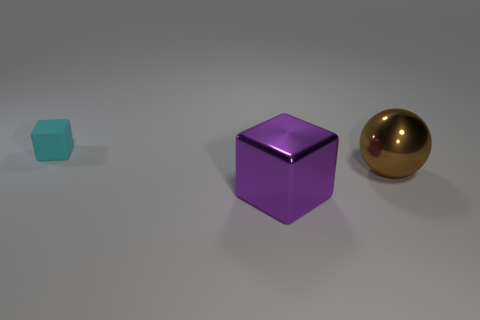Is there a yellow cube made of the same material as the large purple object?
Your answer should be very brief. No. The cube in front of the rubber object is what color?
Ensure brevity in your answer.  Purple. Is the number of cyan matte cubes that are right of the cyan matte thing the same as the number of small cyan blocks in front of the sphere?
Your response must be concise. Yes. There is a block to the left of the metal thing to the left of the sphere; what is its material?
Offer a very short reply. Rubber. How many things are brown balls or objects on the left side of the big metal sphere?
Offer a very short reply. 3. There is a object that is the same material as the large sphere; what size is it?
Offer a terse response. Large. Is the number of large shiny spheres on the left side of the cyan matte block greater than the number of cyan objects?
Offer a terse response. No. There is a object that is both behind the large block and left of the big ball; what size is it?
Ensure brevity in your answer.  Small. What material is the purple object that is the same shape as the small cyan rubber object?
Your answer should be very brief. Metal. Is the size of the cube that is in front of the rubber thing the same as the big brown sphere?
Offer a very short reply. Yes. 